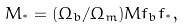Convert formula to latex. <formula><loc_0><loc_0><loc_500><loc_500>M _ { ^ { * } } = ( \Omega _ { b } / \Omega _ { m } ) M f _ { b } f _ { ^ { * } } ,</formula> 